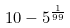Convert formula to latex. <formula><loc_0><loc_0><loc_500><loc_500>1 0 - 5 ^ { \frac { 1 } { 9 9 } }</formula> 